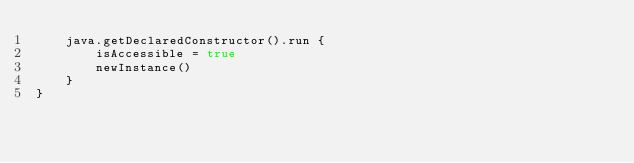Convert code to text. <code><loc_0><loc_0><loc_500><loc_500><_Kotlin_>    java.getDeclaredConstructor().run {
        isAccessible = true
        newInstance()
    }
}</code> 